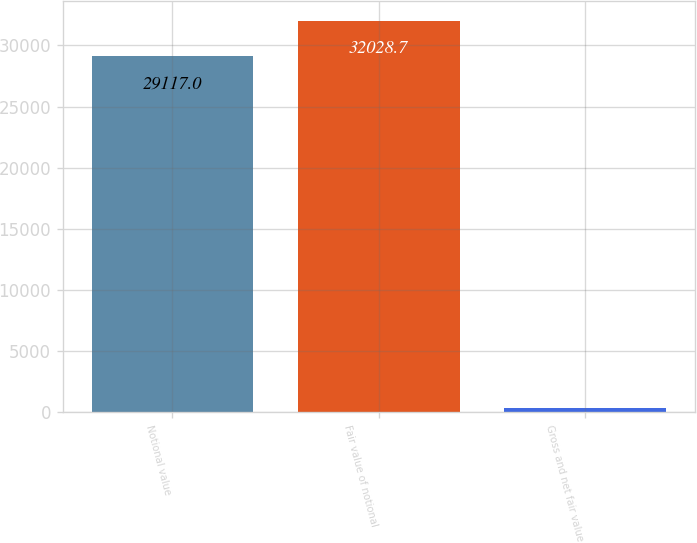Convert chart to OTSL. <chart><loc_0><loc_0><loc_500><loc_500><bar_chart><fcel>Notional value<fcel>Fair value of notional<fcel>Gross and net fair value<nl><fcel>29117<fcel>32028.7<fcel>337<nl></chart> 